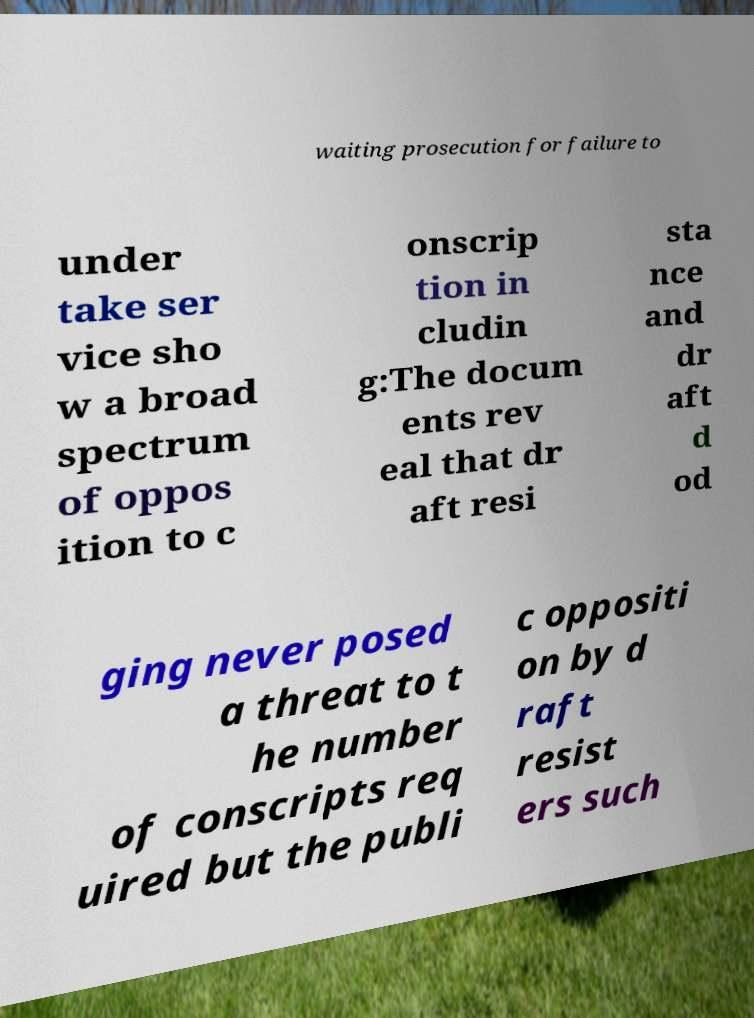There's text embedded in this image that I need extracted. Can you transcribe it verbatim? waiting prosecution for failure to under take ser vice sho w a broad spectrum of oppos ition to c onscrip tion in cludin g:The docum ents rev eal that dr aft resi sta nce and dr aft d od ging never posed a threat to t he number of conscripts req uired but the publi c oppositi on by d raft resist ers such 